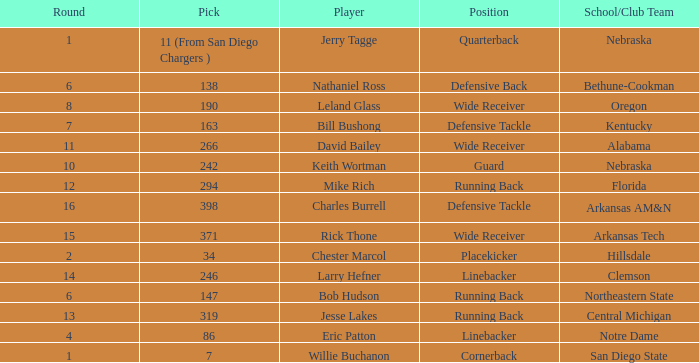Which player is it that has a pick of 147? Bob Hudson. 